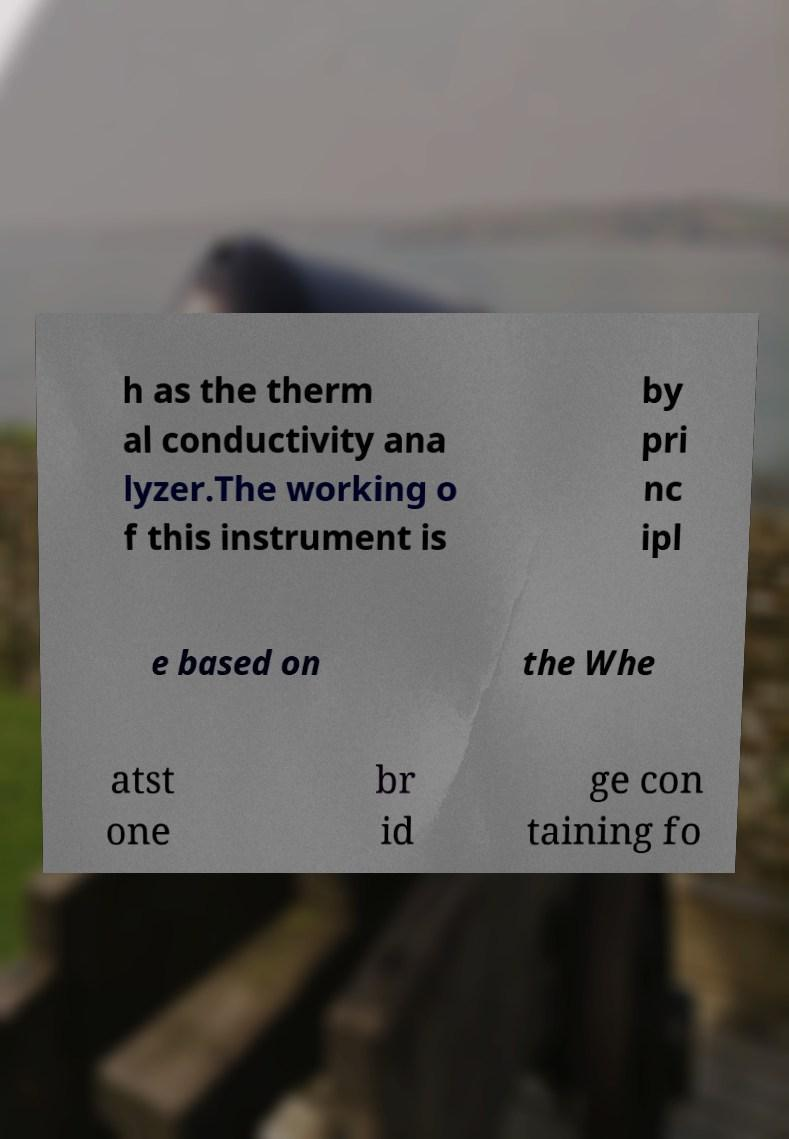Please identify and transcribe the text found in this image. h as the therm al conductivity ana lyzer.The working o f this instrument is by pri nc ipl e based on the Whe atst one br id ge con taining fo 